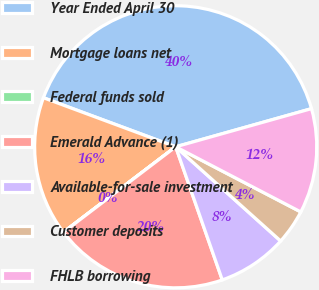Convert chart. <chart><loc_0><loc_0><loc_500><loc_500><pie_chart><fcel>Year Ended April 30<fcel>Mortgage loans net<fcel>Federal funds sold<fcel>Emerald Advance (1)<fcel>Available-for-sale investment<fcel>Customer deposits<fcel>FHLB borrowing<nl><fcel>39.99%<fcel>16.0%<fcel>0.01%<fcel>20.0%<fcel>8.0%<fcel>4.0%<fcel>12.0%<nl></chart> 